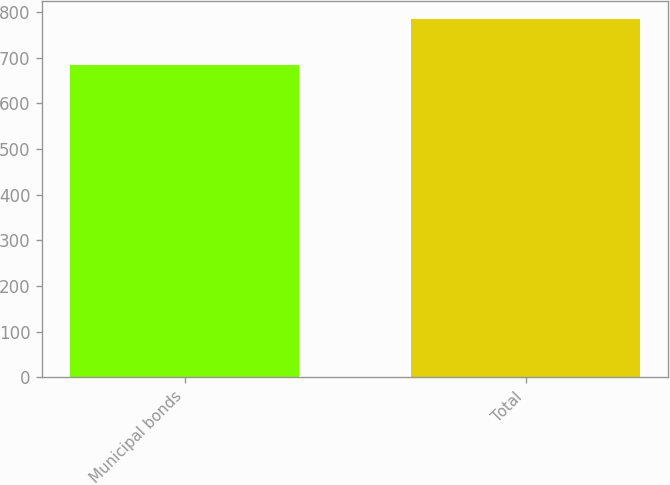Convert chart to OTSL. <chart><loc_0><loc_0><loc_500><loc_500><bar_chart><fcel>Municipal bonds<fcel>Total<nl><fcel>685<fcel>785<nl></chart> 